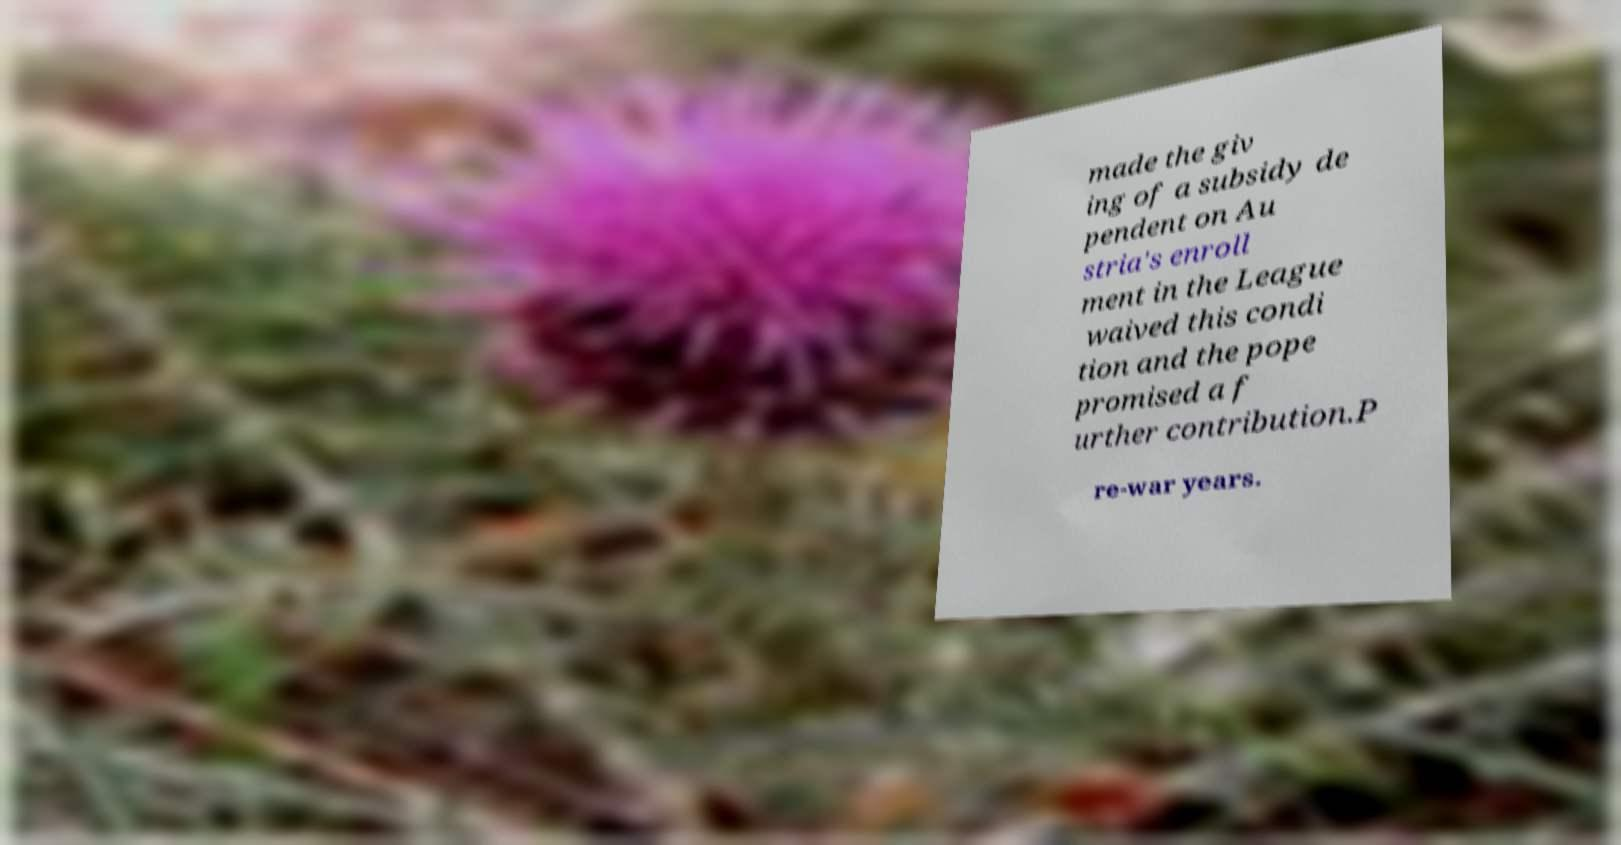Could you assist in decoding the text presented in this image and type it out clearly? made the giv ing of a subsidy de pendent on Au stria's enroll ment in the League waived this condi tion and the pope promised a f urther contribution.P re-war years. 